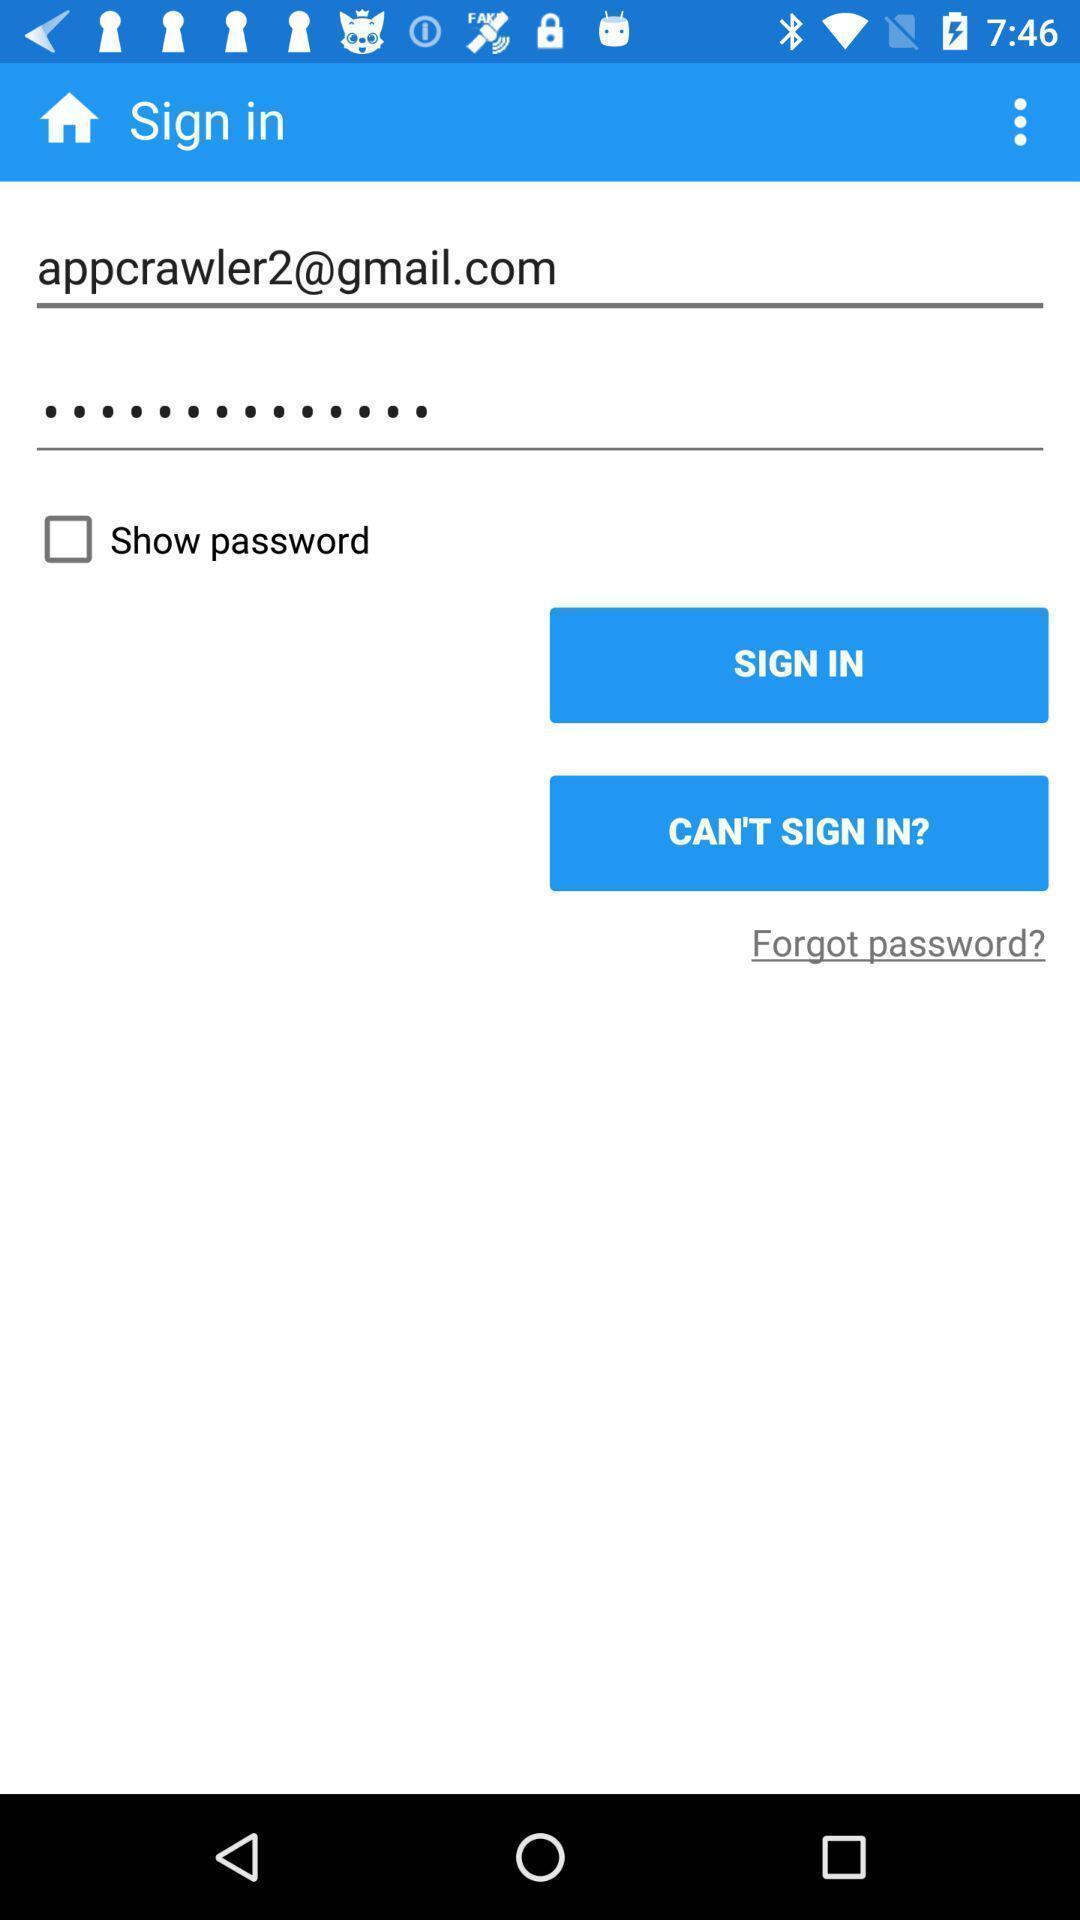Give me a summary of this screen capture. Sign in page. 